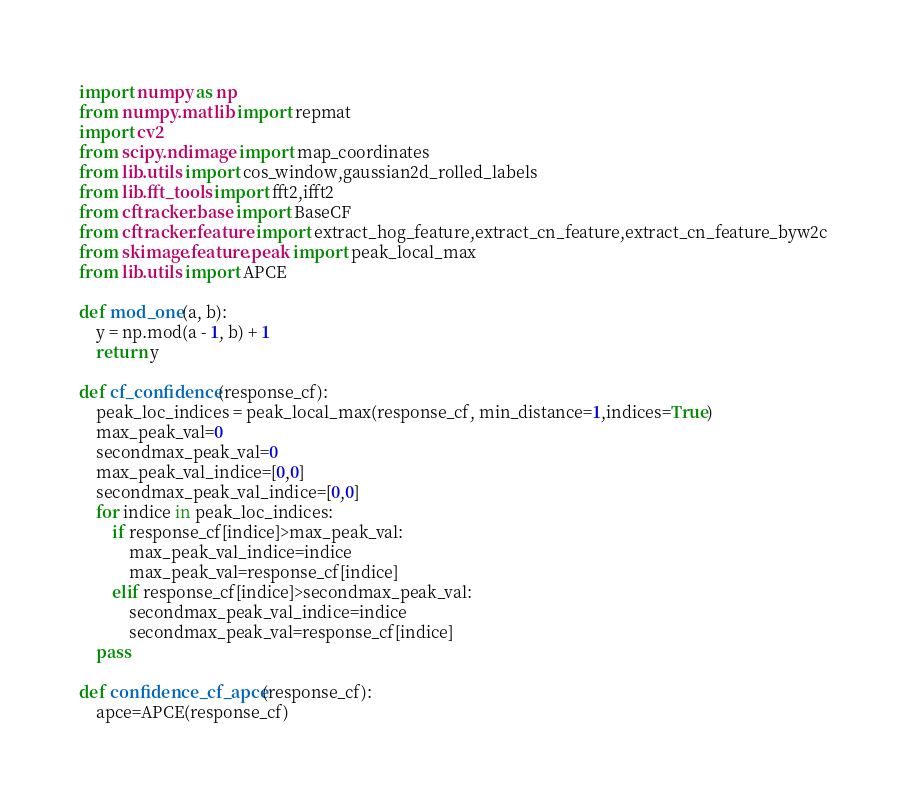Convert code to text. <code><loc_0><loc_0><loc_500><loc_500><_Python_>import numpy as np
from numpy.matlib import repmat
import cv2
from scipy.ndimage import map_coordinates
from lib.utils import cos_window,gaussian2d_rolled_labels
from lib.fft_tools import fft2,ifft2
from cftracker.base import BaseCF
from cftracker.feature import extract_hog_feature,extract_cn_feature,extract_cn_feature_byw2c
from skimage.feature.peak import peak_local_max
from lib.utils import APCE

def mod_one(a, b):
    y = np.mod(a - 1, b) + 1
    return y

def cf_confidence(response_cf):
    peak_loc_indices = peak_local_max(response_cf, min_distance=1,indices=True)
    max_peak_val=0
    secondmax_peak_val=0
    max_peak_val_indice=[0,0]
    secondmax_peak_val_indice=[0,0]
    for indice in peak_loc_indices:
        if response_cf[indice]>max_peak_val:
            max_peak_val_indice=indice
            max_peak_val=response_cf[indice]
        elif response_cf[indice]>secondmax_peak_val:
            secondmax_peak_val_indice=indice
            secondmax_peak_val=response_cf[indice]
    pass

def confidence_cf_apce(response_cf):
    apce=APCE(response_cf)</code> 